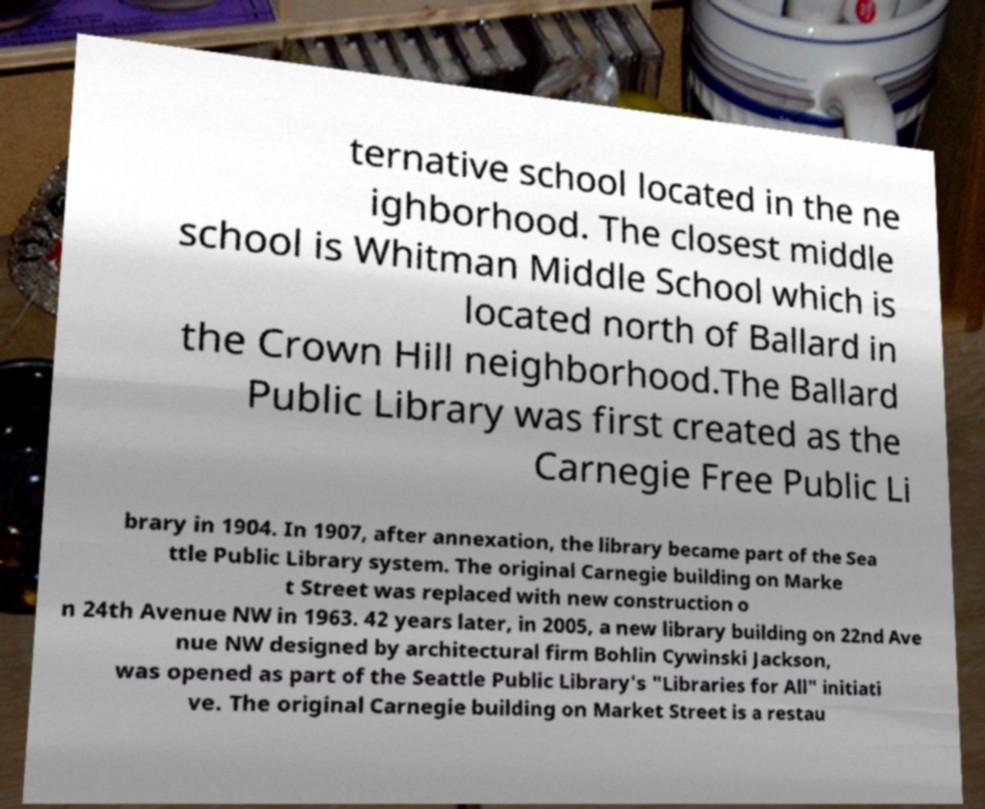Can you accurately transcribe the text from the provided image for me? ternative school located in the ne ighborhood. The closest middle school is Whitman Middle School which is located north of Ballard in the Crown Hill neighborhood.The Ballard Public Library was first created as the Carnegie Free Public Li brary in 1904. In 1907, after annexation, the library became part of the Sea ttle Public Library system. The original Carnegie building on Marke t Street was replaced with new construction o n 24th Avenue NW in 1963. 42 years later, in 2005, a new library building on 22nd Ave nue NW designed by architectural firm Bohlin Cywinski Jackson, was opened as part of the Seattle Public Library's "Libraries for All" initiati ve. The original Carnegie building on Market Street is a restau 